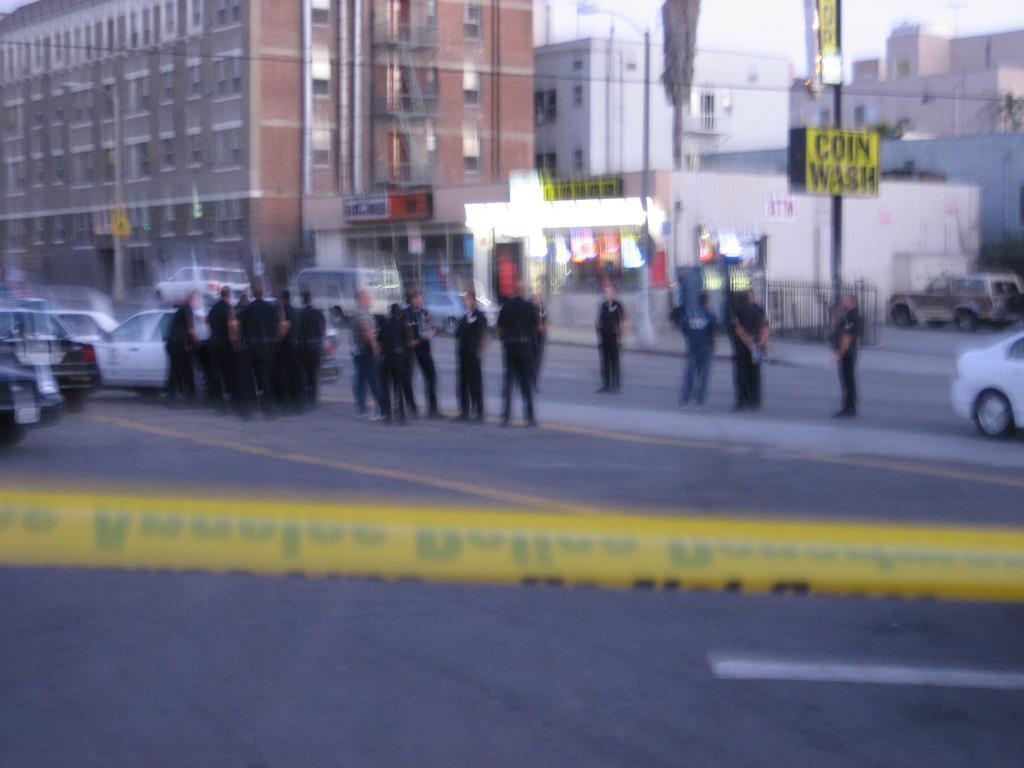Can you describe this image briefly? This is an outdoor picture. On the background of the picture we can see huge buildings. This is the store and there are few vehicles on the road and here we can see few policemen standing on the road. This is the pole and in front of the picture we can see some yellow cover sign of rope. 